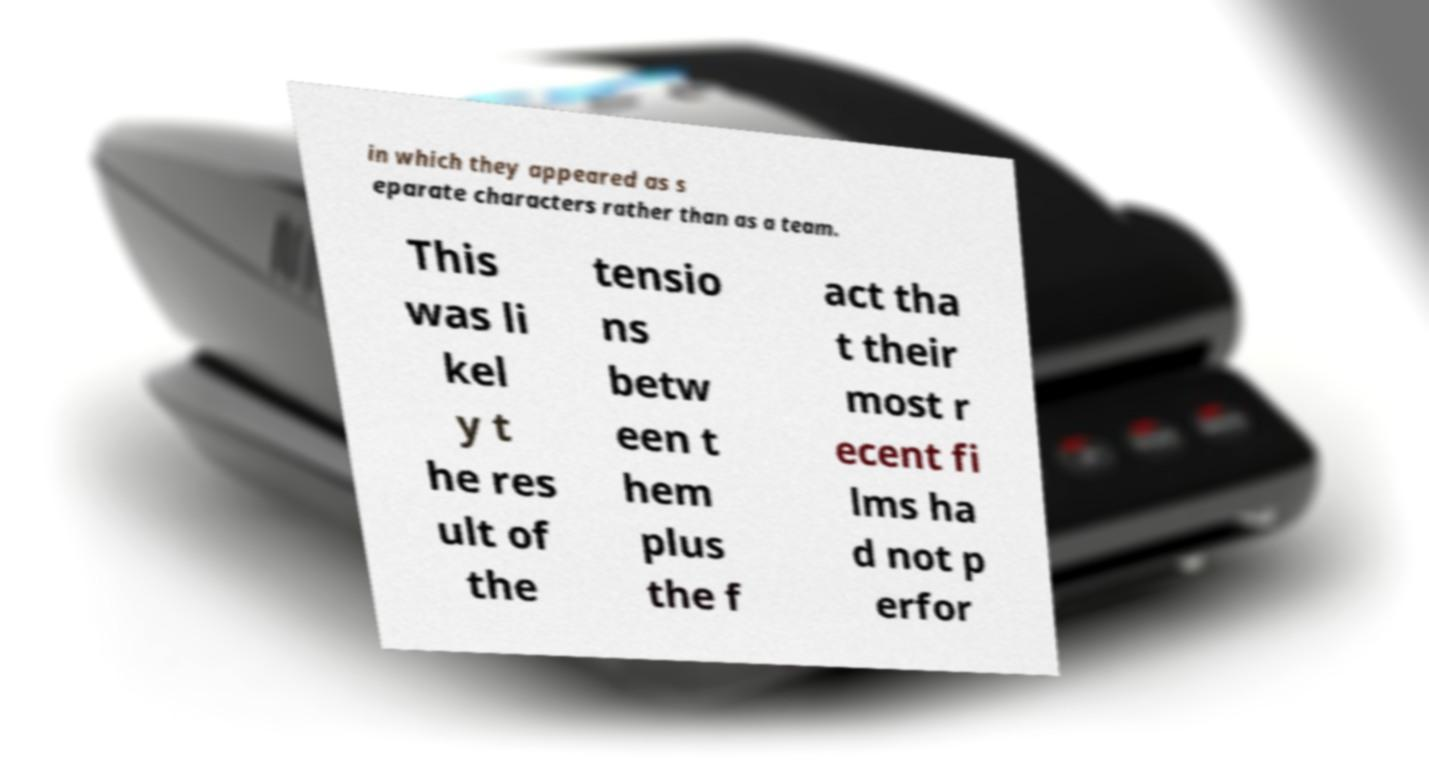What messages or text are displayed in this image? I need them in a readable, typed format. in which they appeared as s eparate characters rather than as a team. This was li kel y t he res ult of the tensio ns betw een t hem plus the f act tha t their most r ecent fi lms ha d not p erfor 